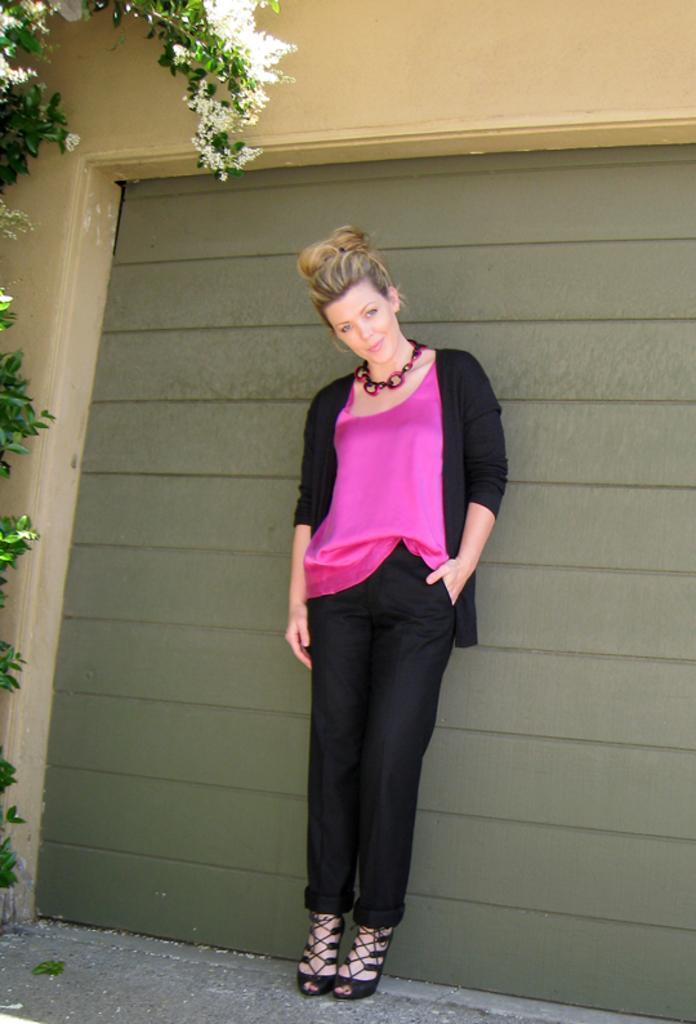How would you summarize this image in a sentence or two? In this image, we can see a person wearing clothes and standing in front of the wall. There is a tree on the left side of the image. 